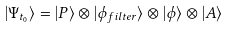<formula> <loc_0><loc_0><loc_500><loc_500>| { \Psi } _ { t _ { 0 } } \rangle = | P \rangle \otimes | \phi _ { f i l t e r } \rangle \otimes | \phi \rangle \otimes | A \rangle</formula> 